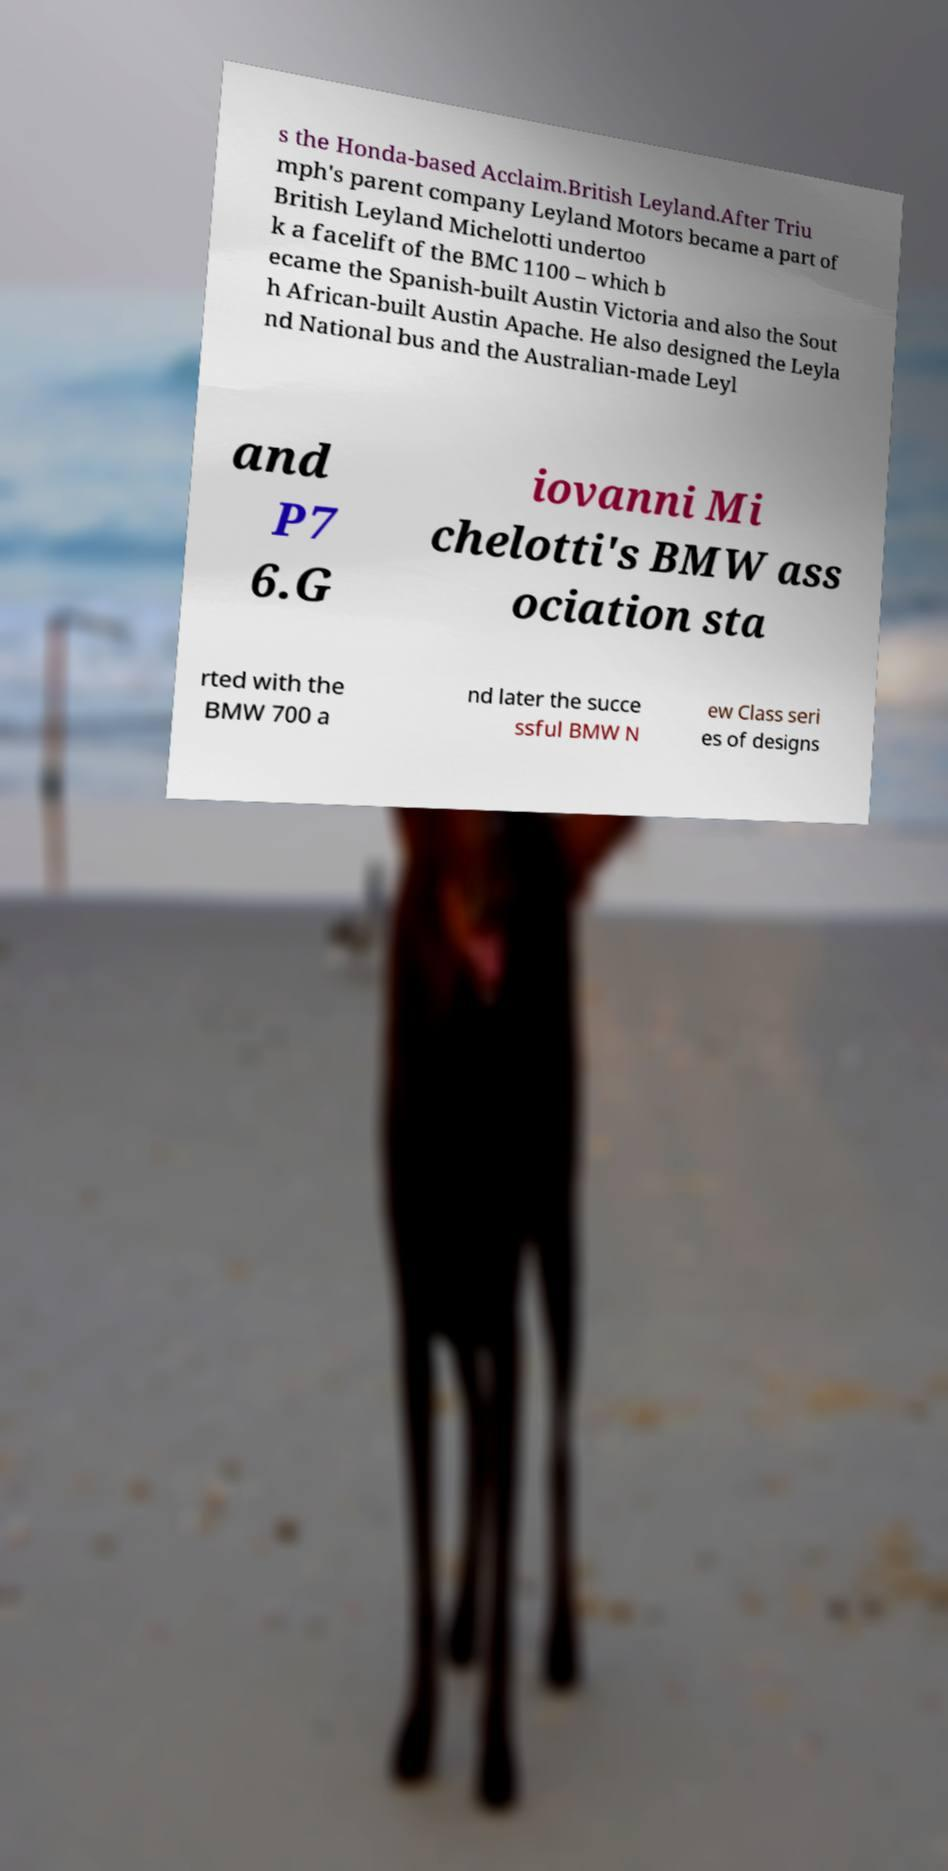For documentation purposes, I need the text within this image transcribed. Could you provide that? s the Honda-based Acclaim.British Leyland.After Triu mph's parent company Leyland Motors became a part of British Leyland Michelotti undertoo k a facelift of the BMC 1100 – which b ecame the Spanish-built Austin Victoria and also the Sout h African-built Austin Apache. He also designed the Leyla nd National bus and the Australian-made Leyl and P7 6.G iovanni Mi chelotti's BMW ass ociation sta rted with the BMW 700 a nd later the succe ssful BMW N ew Class seri es of designs 